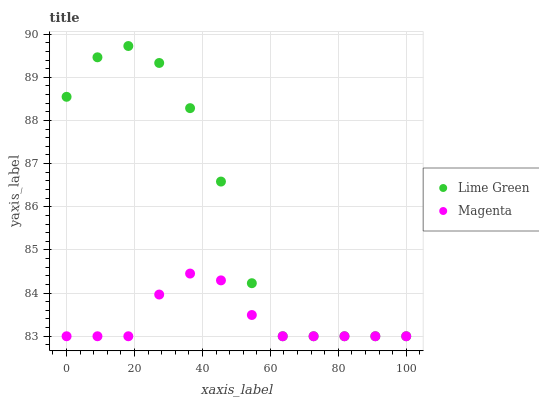Does Magenta have the minimum area under the curve?
Answer yes or no. Yes. Does Lime Green have the maximum area under the curve?
Answer yes or no. Yes. Does Lime Green have the minimum area under the curve?
Answer yes or no. No. Is Magenta the smoothest?
Answer yes or no. Yes. Is Lime Green the roughest?
Answer yes or no. Yes. Is Lime Green the smoothest?
Answer yes or no. No. Does Magenta have the lowest value?
Answer yes or no. Yes. Does Lime Green have the highest value?
Answer yes or no. Yes. Does Magenta intersect Lime Green?
Answer yes or no. Yes. Is Magenta less than Lime Green?
Answer yes or no. No. Is Magenta greater than Lime Green?
Answer yes or no. No. 